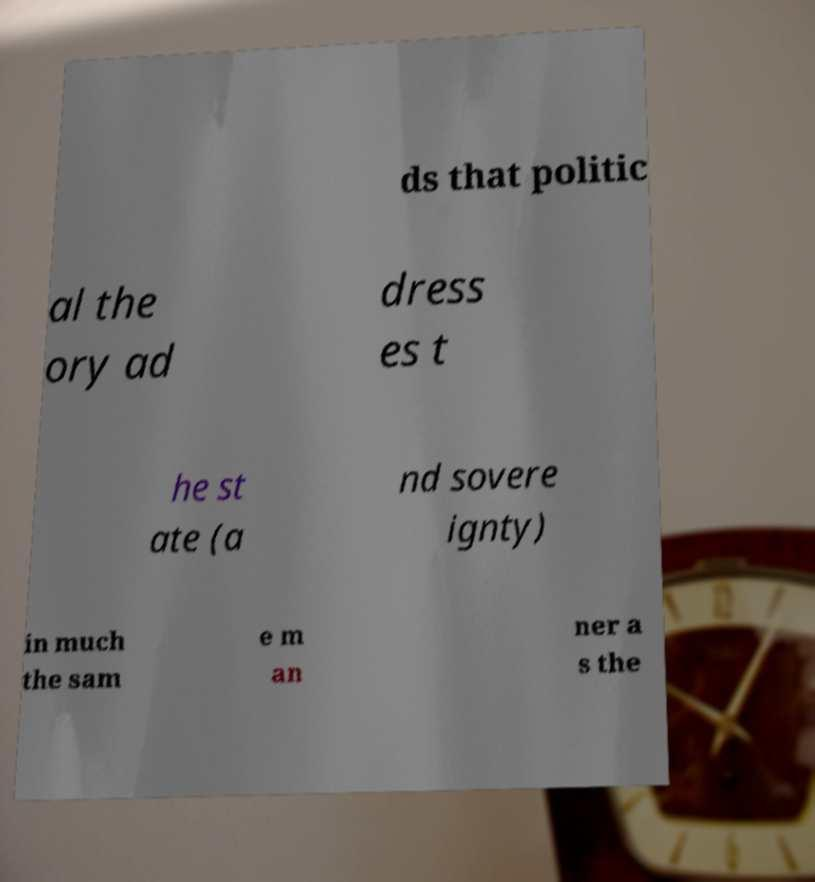Can you read and provide the text displayed in the image?This photo seems to have some interesting text. Can you extract and type it out for me? ds that politic al the ory ad dress es t he st ate (a nd sovere ignty) in much the sam e m an ner a s the 